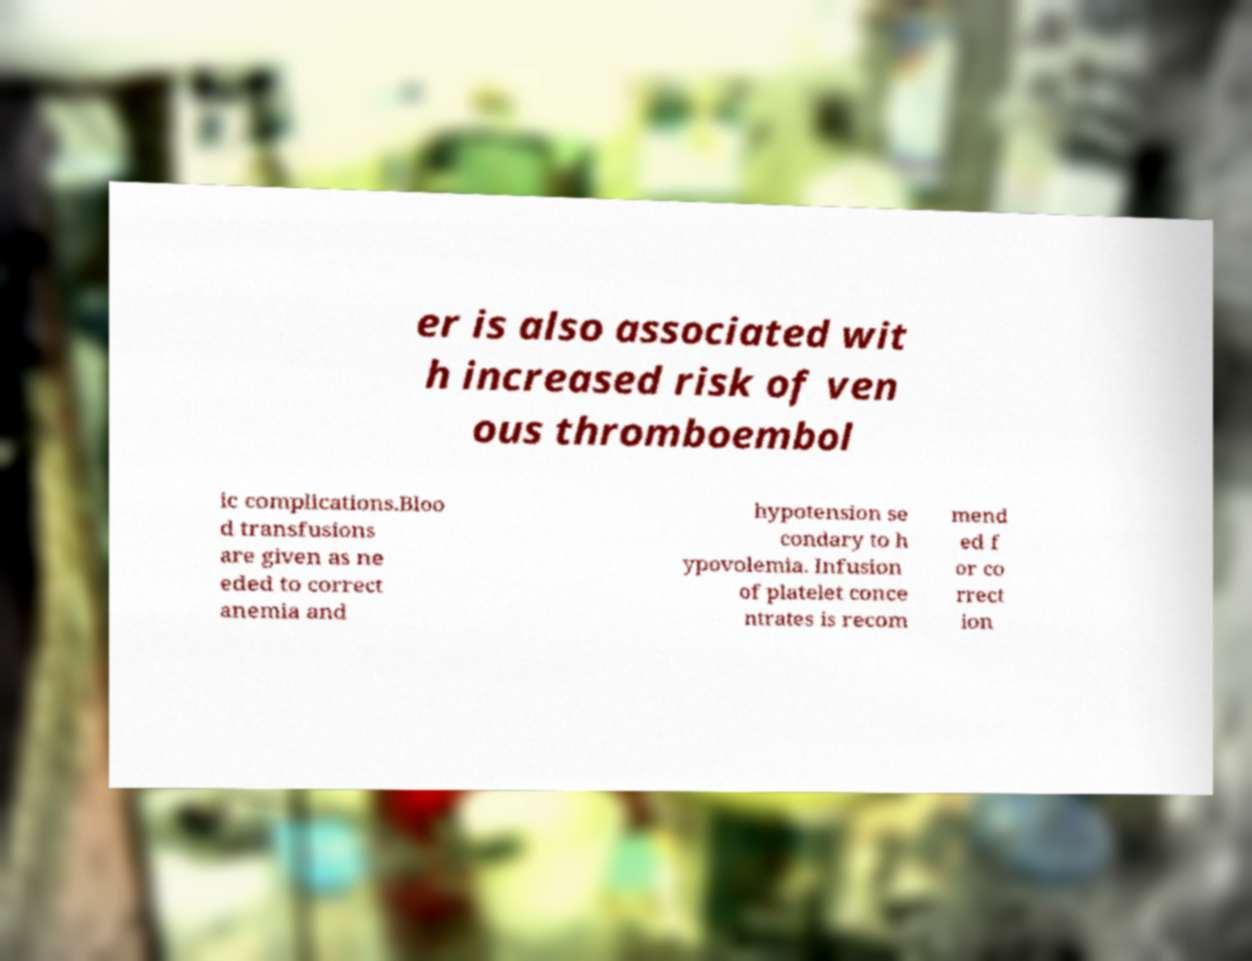Could you extract and type out the text from this image? er is also associated wit h increased risk of ven ous thromboembol ic complications.Bloo d transfusions are given as ne eded to correct anemia and hypotension se condary to h ypovolemia. Infusion of platelet conce ntrates is recom mend ed f or co rrect ion 